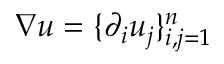Convert formula to latex. <formula><loc_0><loc_0><loc_500><loc_500>\nabla u = \{ \partial _ { i } u _ { j } \} _ { i , j = 1 } ^ { n }</formula> 